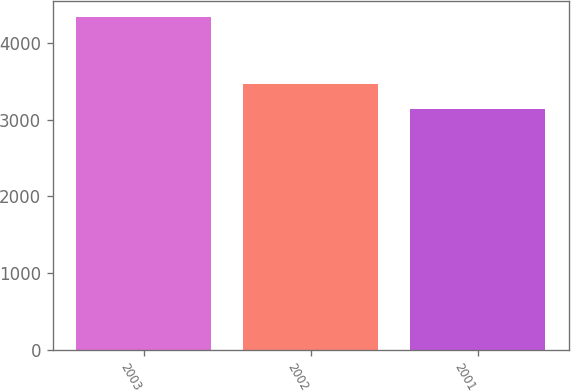Convert chart. <chart><loc_0><loc_0><loc_500><loc_500><bar_chart><fcel>2003<fcel>2002<fcel>2001<nl><fcel>4337.3<fcel>3467.4<fcel>3134.3<nl></chart> 